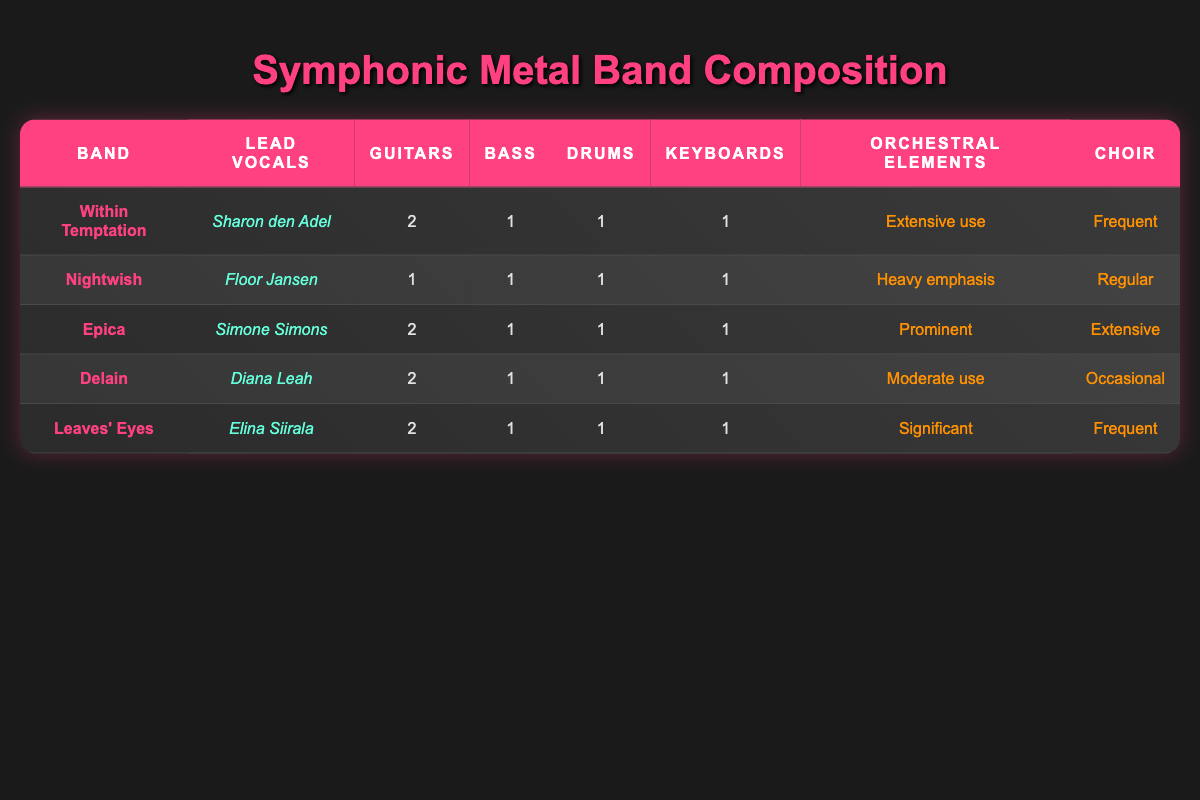What is the name of the lead vocalist for Within Temptation? The band Within Temptation's lead vocalist is listed in the "Lead Vocals" column for that band row. It is Sharon den Adel.
Answer: Sharon den Adel How many guitars are used in Epica? Looking at the row for Epica, the number of guitars is stated as "2" in the "Guitars" column.
Answer: 2 Does Nightwish have frequent use of choir? Nightwish's "Choir" column states "Regular," which means it is not frequent. Therefore, the answer is false.
Answer: No Which band has extensive use of orchestral elements? Within Temptation has "Extensive use" written in the "Orchestral Elements" column, among the data.
Answer: Within Temptation What is the total number of guitars used by Delain and Leaves' Eyes combined? Delain's number of guitars is 2, and Leaves' Eyes also has 2. Adding these together gives us 2 + 2 = 4.
Answer: 4 Is the lead vocalist of Epica male? The row for Epica states the lead vocalist is Simone Simons, which is a female name. Therefore, it is false.
Answer: No Which band has the heaviest emphasis on orchestral elements? Upon reviewing the orchestral elements descriptions, Nightwish has "Heavy emphasis." No other band matches this level.
Answer: Nightwish Do all bands have at least one drummer? Each band in the table lists "1" under the "Drums" column, confirming that they all have at least one drummer.
Answer: Yes What percentage of the listed bands have "Frequent" choir use? There are two bands, Within Temptation and Leaves' Eyes, that have "Frequent" choir use out of the five listed. Therefore, the percentage is (2/5) * 100 = 40%.
Answer: 40% 